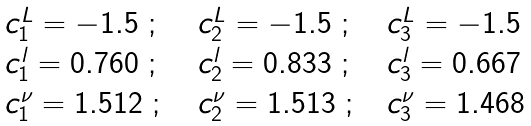Convert formula to latex. <formula><loc_0><loc_0><loc_500><loc_500>\begin{array} { l l l } c _ { 1 } ^ { L } = - 1 . 5 \ ; \ \ & c _ { 2 } ^ { L } = - 1 . 5 \ ; \ \ & c _ { 3 } ^ { L } = - 1 . 5 \\ c _ { 1 } ^ { l } = 0 . 7 6 0 \ ; \ \ & c _ { 2 } ^ { l } = 0 . 8 3 3 \ ; \ \ & c _ { 3 } ^ { l } = 0 . 6 6 7 \\ c _ { 1 } ^ { \nu } = 1 . 5 1 2 \ ; \ \ & c _ { 2 } ^ { \nu } = 1 . 5 1 3 \ ; \ & c _ { 3 } ^ { \nu } = 1 . 4 6 8 \end{array}</formula> 